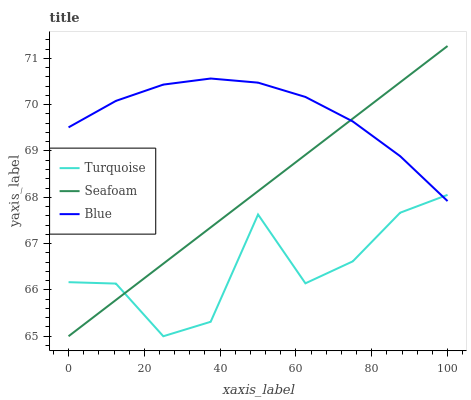Does Turquoise have the minimum area under the curve?
Answer yes or no. Yes. Does Blue have the maximum area under the curve?
Answer yes or no. Yes. Does Seafoam have the minimum area under the curve?
Answer yes or no. No. Does Seafoam have the maximum area under the curve?
Answer yes or no. No. Is Seafoam the smoothest?
Answer yes or no. Yes. Is Turquoise the roughest?
Answer yes or no. Yes. Is Turquoise the smoothest?
Answer yes or no. No. Is Seafoam the roughest?
Answer yes or no. No. Does Turquoise have the lowest value?
Answer yes or no. Yes. Does Seafoam have the highest value?
Answer yes or no. Yes. Does Turquoise have the highest value?
Answer yes or no. No. Does Turquoise intersect Seafoam?
Answer yes or no. Yes. Is Turquoise less than Seafoam?
Answer yes or no. No. Is Turquoise greater than Seafoam?
Answer yes or no. No. 